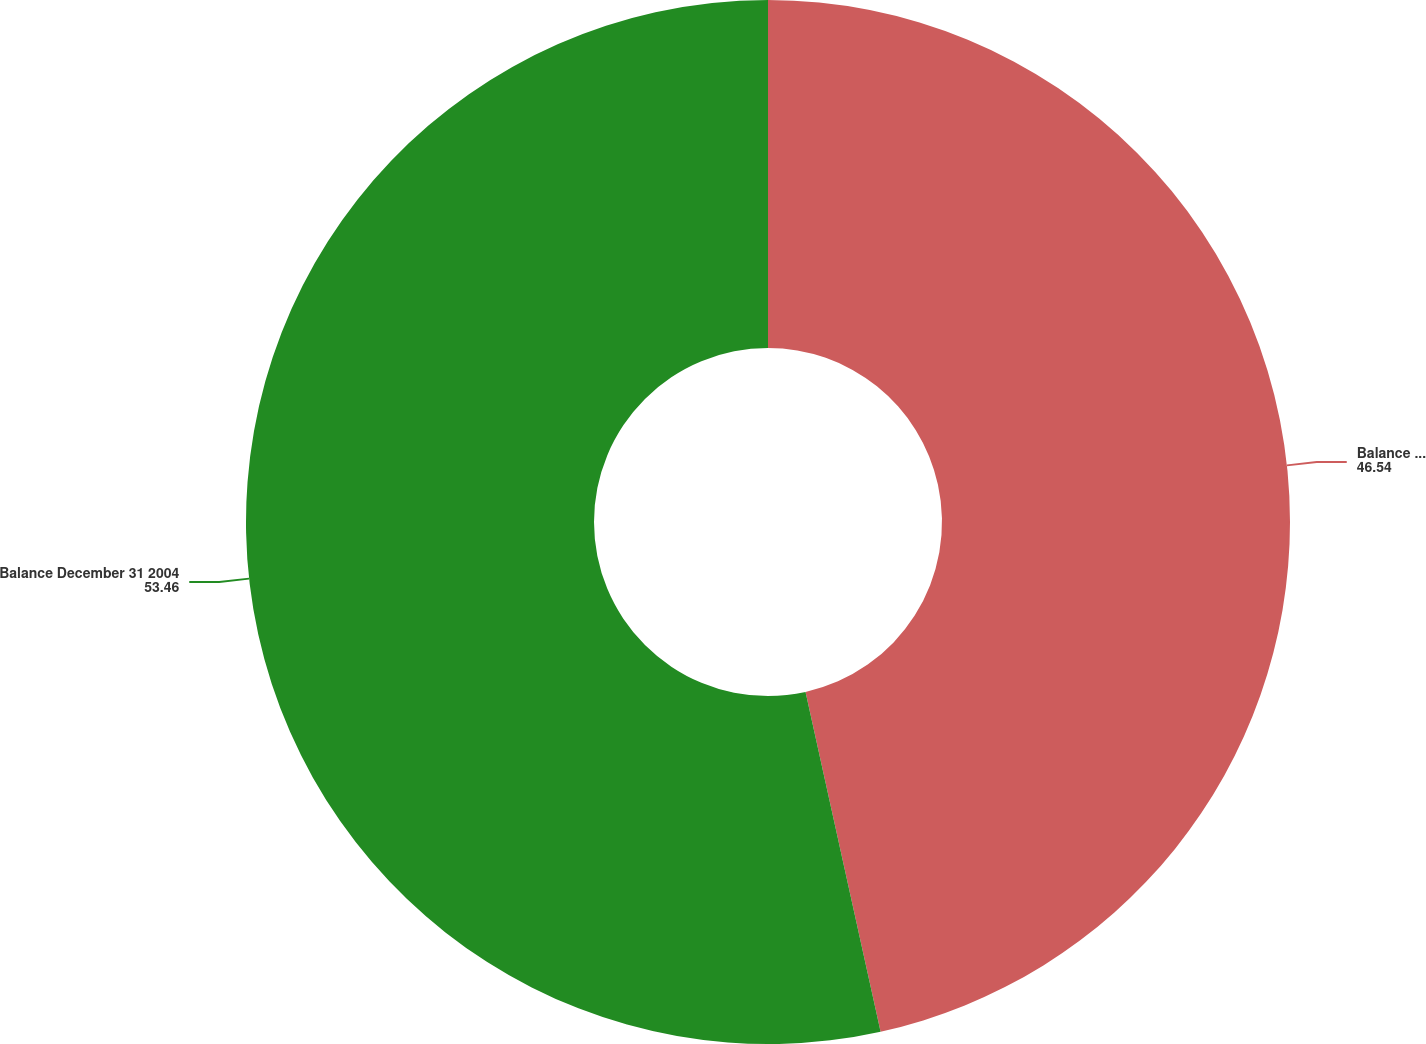Convert chart. <chart><loc_0><loc_0><loc_500><loc_500><pie_chart><fcel>Balance December 31 2003<fcel>Balance December 31 2004<nl><fcel>46.54%<fcel>53.46%<nl></chart> 